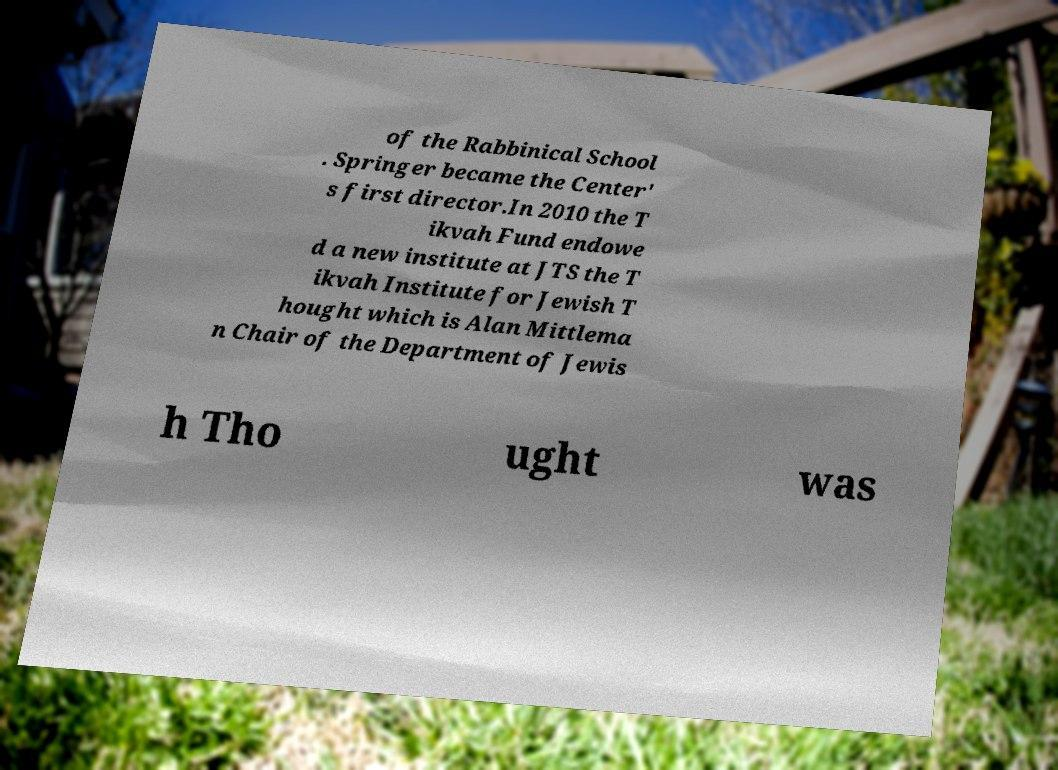Can you accurately transcribe the text from the provided image for me? of the Rabbinical School . Springer became the Center' s first director.In 2010 the T ikvah Fund endowe d a new institute at JTS the T ikvah Institute for Jewish T hought which is Alan Mittlema n Chair of the Department of Jewis h Tho ught was 